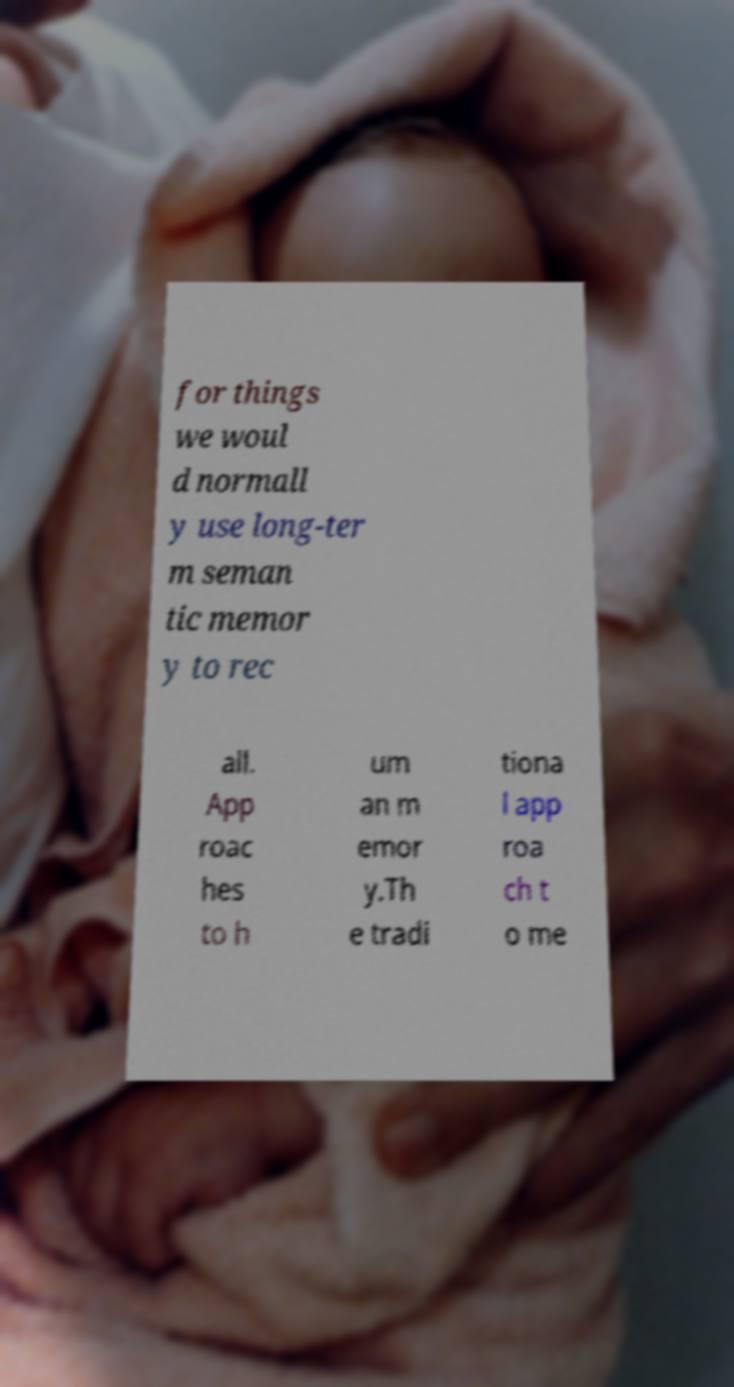There's text embedded in this image that I need extracted. Can you transcribe it verbatim? for things we woul d normall y use long-ter m seman tic memor y to rec all. App roac hes to h um an m emor y.Th e tradi tiona l app roa ch t o me 